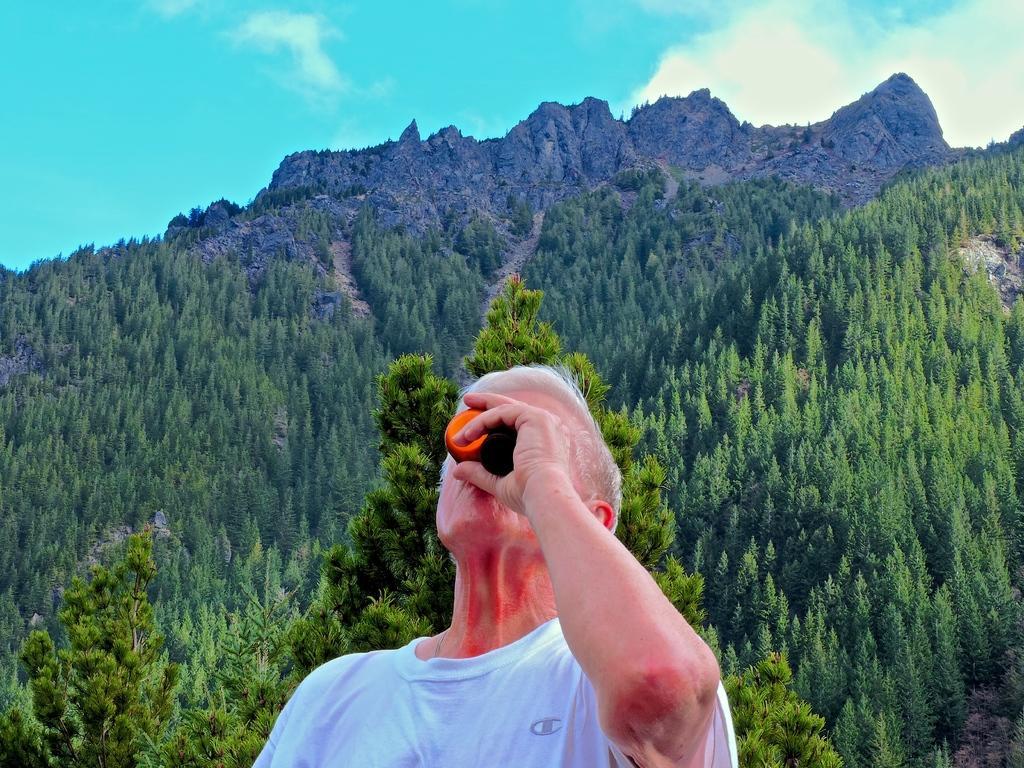In one or two sentences, can you explain what this image depicts? In this image in the foreground there is a man wearing white t-shirt. He is holding something. In the background there are trees, hills. The sky is cloudy. 